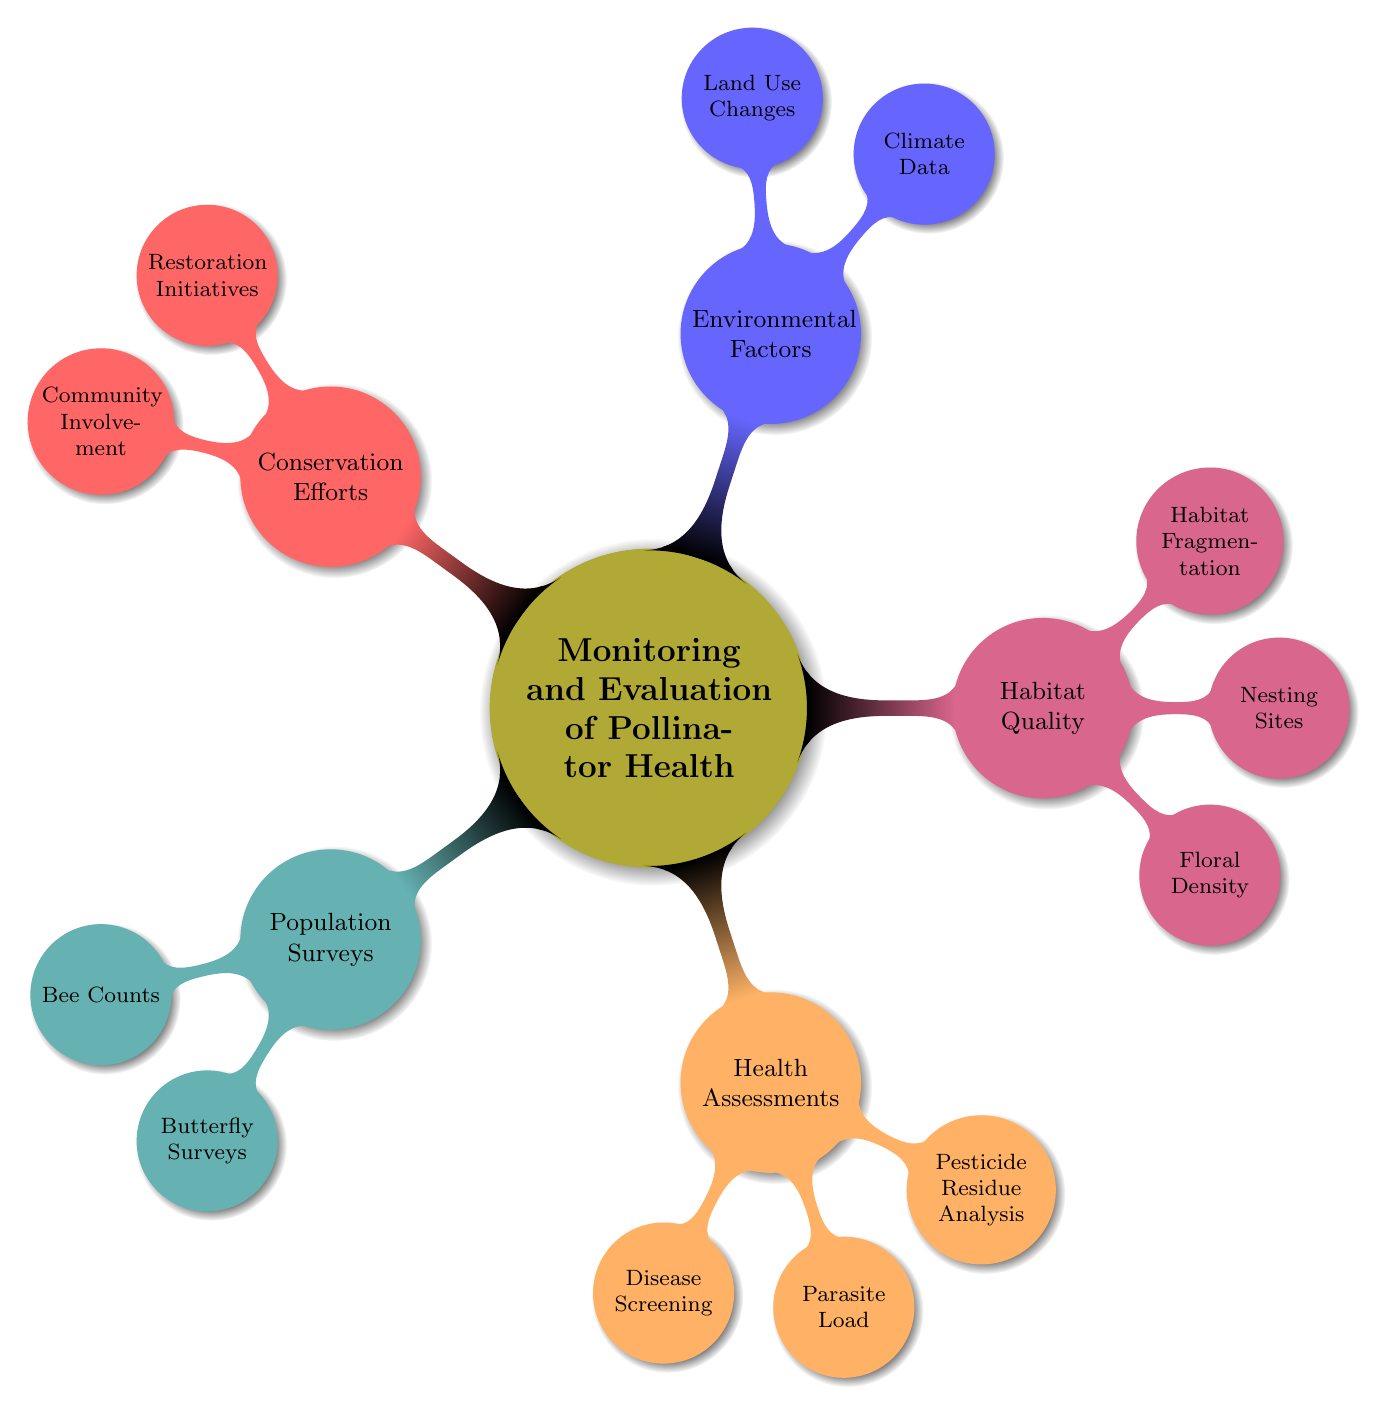What are the two types of population surveys mentioned? The diagram specifies that two types of population surveys are "Bee Counts" and "Butterfly Surveys" under the "Population Surveys" node.
Answer: Bee Counts, Butterfly Surveys How many health assessments are listed in the diagram? The diagram lists three health assessments: "Disease Screening," "Parasite Load," and "Pesticide Residue Analysis." Therefore, there are a total of three health assessments.
Answer: 3 Which environmental factor is concerned with future changes in land usage? The diagram indicates that "Land Use Changes" is an environmental factor that relates to urban and agricultural development, implying concerns about future land usage changes.
Answer: Land Use Changes What habitat quality aspect refers to the availability of food for pollinators? The aspect that refers to the availability of food resources for pollinators is "Floral Density," as it indicates the availability of foraging resources.
Answer: Floral Density Name one restoration initiative listed under conservation efforts. The diagram indicates that "Reforestation Projects" is a type of restoration initiative mentioned under conservation efforts.
Answer: Reforestation Projects What is the relationship between "Nesting Sites" and "Nest Box Monitoring"? The diagram shows that "Nesting Sites" is a child node under "Habitat Quality," and "Nest Box Monitoring" is the descriptive phrase indicating how the nesting sites are observed or evaluated. Thus, "Nest Box Monitoring" relates to assessing "Nesting Sites."
Answer: Nest Box Monitoring How many main branches are present in this mind map? The mind map features five main branches stemming from the central node "Monitoring and Evaluation of Pollinator Health." These branches are "Population Surveys," "Health Assessments," "Habitat Quality," "Environmental Factors," and "Conservation Efforts." Thus, there are five main branches.
Answer: 5 What type of survey is conducted seasonally? The diagram states "Seasonal Fly Counts" under the "Butterfly Surveys" node, which indicates that a survey of butterflies is conducted on a seasonal basis.
Answer: Seasonal Fly Counts Which type of analysis assesses pesticide exposure in crop fields? Under "Health Assessments," the "Pesticide Residue Analysis" node explains that it focuses on evaluating exposure in crop fields.
Answer: Pesticide Residue Analysis 